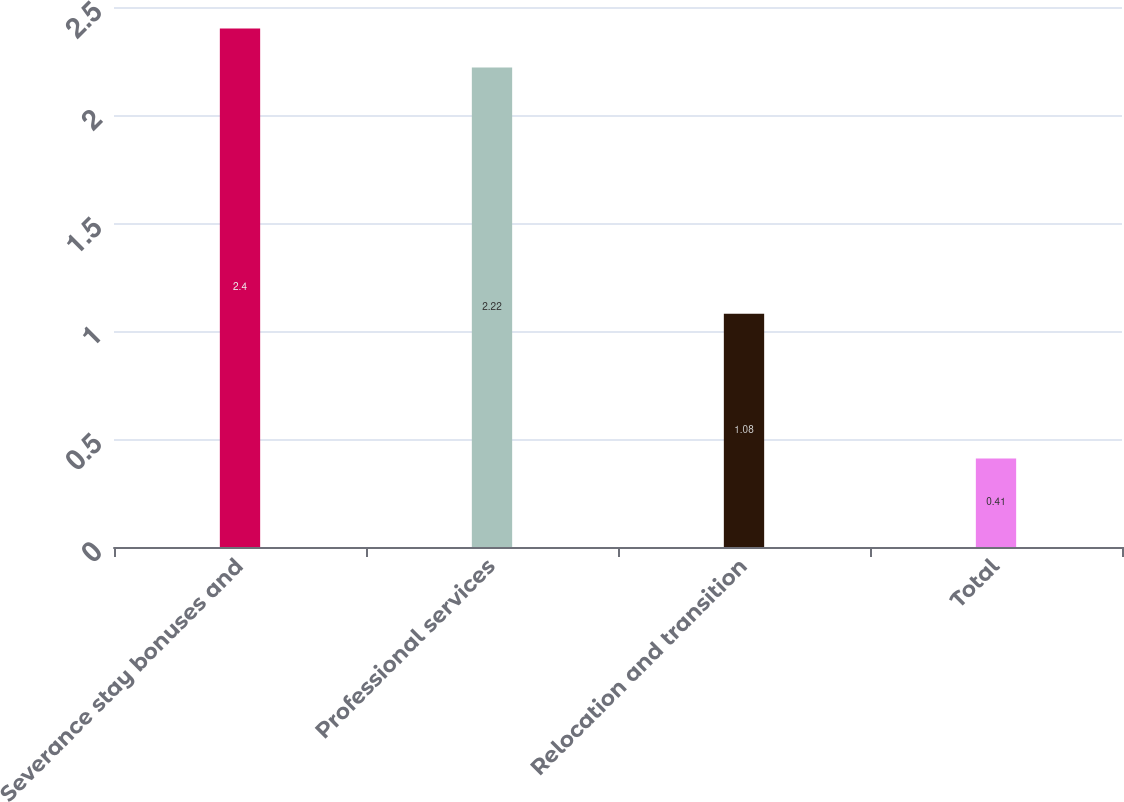Convert chart. <chart><loc_0><loc_0><loc_500><loc_500><bar_chart><fcel>Severance stay bonuses and<fcel>Professional services<fcel>Relocation and transition<fcel>Total<nl><fcel>2.4<fcel>2.22<fcel>1.08<fcel>0.41<nl></chart> 